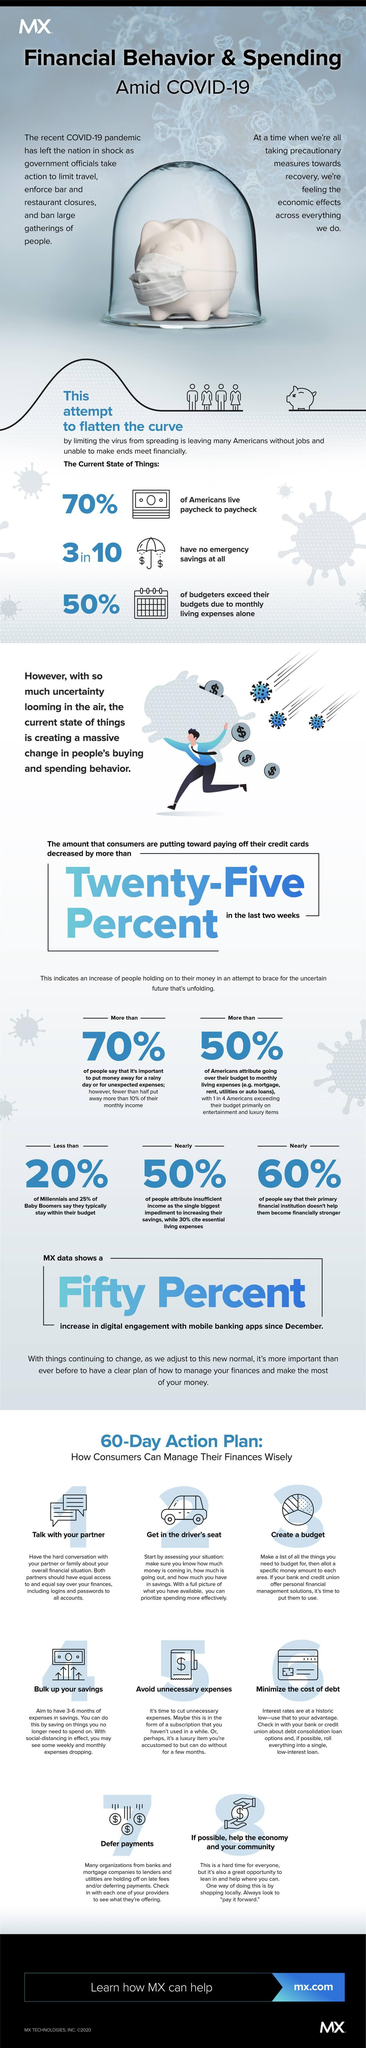What percent of Americans say that their primary financial institution doesn't help them to become financially stronger amid COVID-19?
Answer the question with a short phrase. 60% What percent of millennials say that they typically stay within their budget amid COVID-19? Less than 20% 